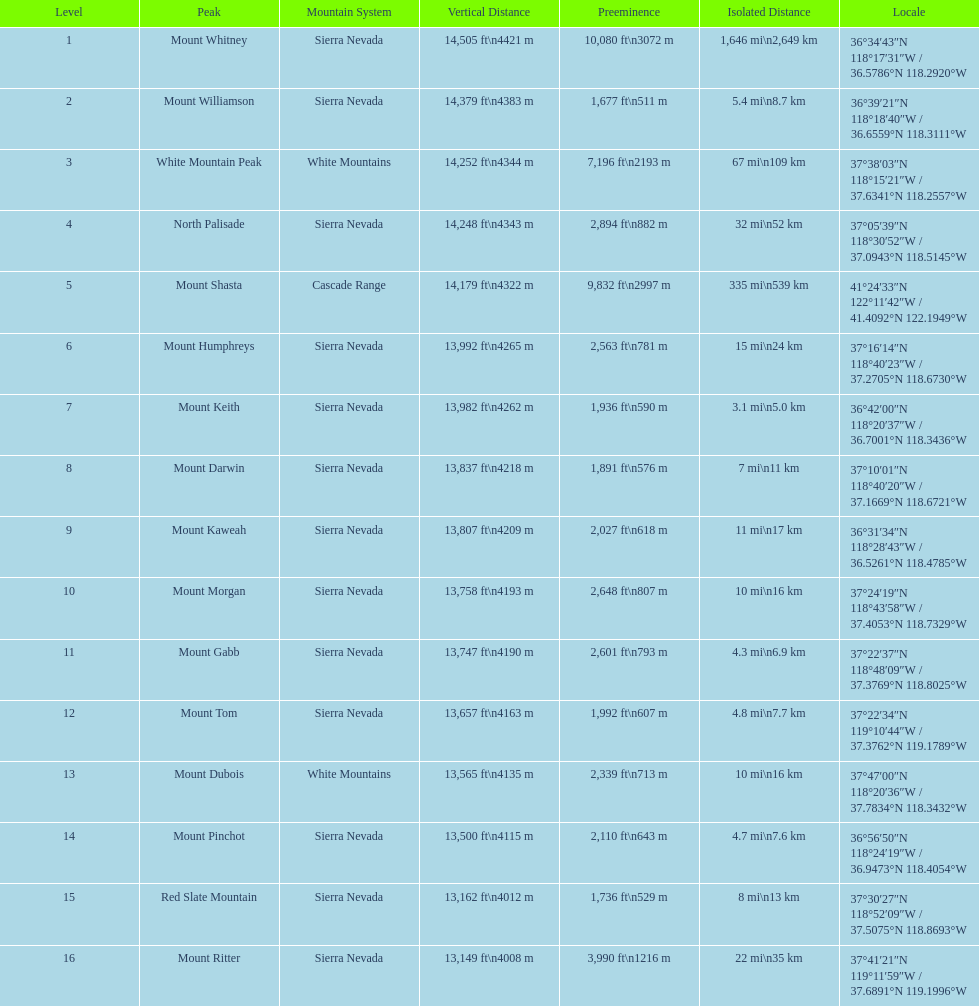Which mountain peak has the least isolation? Mount Keith. 